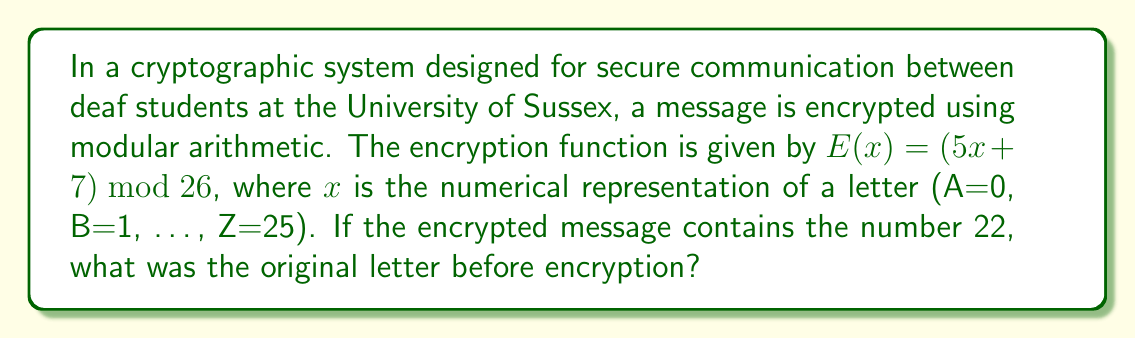Teach me how to tackle this problem. To solve this problem, we need to use the concept of modular arithmetic and find the inverse of the encryption function. Let's approach this step-by-step:

1) The encryption function is $E(x) = (5x + 7) \bmod 26$

2) We need to find $x$ given that $E(x) = 22$. So, we have the equation:
   $$(5x + 7) \bmod 26 = 22$$

3) First, let's subtract 7 from both sides:
   $$(5x) \bmod 26 = 15$$

4) Now, we need to multiply both sides by the modular multiplicative inverse of 5 (mod 26). Let's call this inverse $a$. It satisfies the equation:
   $$(5a) \bmod 26 = 1$$

5) We can find $a$ by trying values or using the extended Euclidean algorithm. In this case, $a = 21$ because:
   $$(5 \cdot 21) \bmod 26 = 105 \bmod 26 = 1$$

6) Multiplying both sides of our equation by 21:
   $$21 \cdot (5x \bmod 26) = 21 \cdot 15 \bmod 26$$
   $$(21 \cdot 5x) \bmod 26 = 315 \bmod 26$$
   $$x \bmod 26 = 5$$

7) Therefore, $x = 5$

8) In our alphabet representation (A=0, B=1, ..., Z=25), the number 5 corresponds to the letter F.
Answer: F 